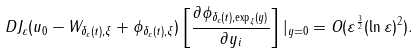Convert formula to latex. <formula><loc_0><loc_0><loc_500><loc_500>D J _ { \varepsilon } ( u _ { 0 } - W _ { \delta _ { \varepsilon } ( t ) , \xi } + \phi _ { \delta _ { \varepsilon } ( t ) , \xi } ) \left [ \frac { \partial \phi _ { \delta _ { \varepsilon } ( t ) , \exp _ { \xi } ( y ) } } { \partial y _ { i } } \right ] | _ { y = 0 } = O ( \varepsilon ^ { \frac { 3 } { 2 } } ( \ln \varepsilon ) ^ { 2 } ) .</formula> 